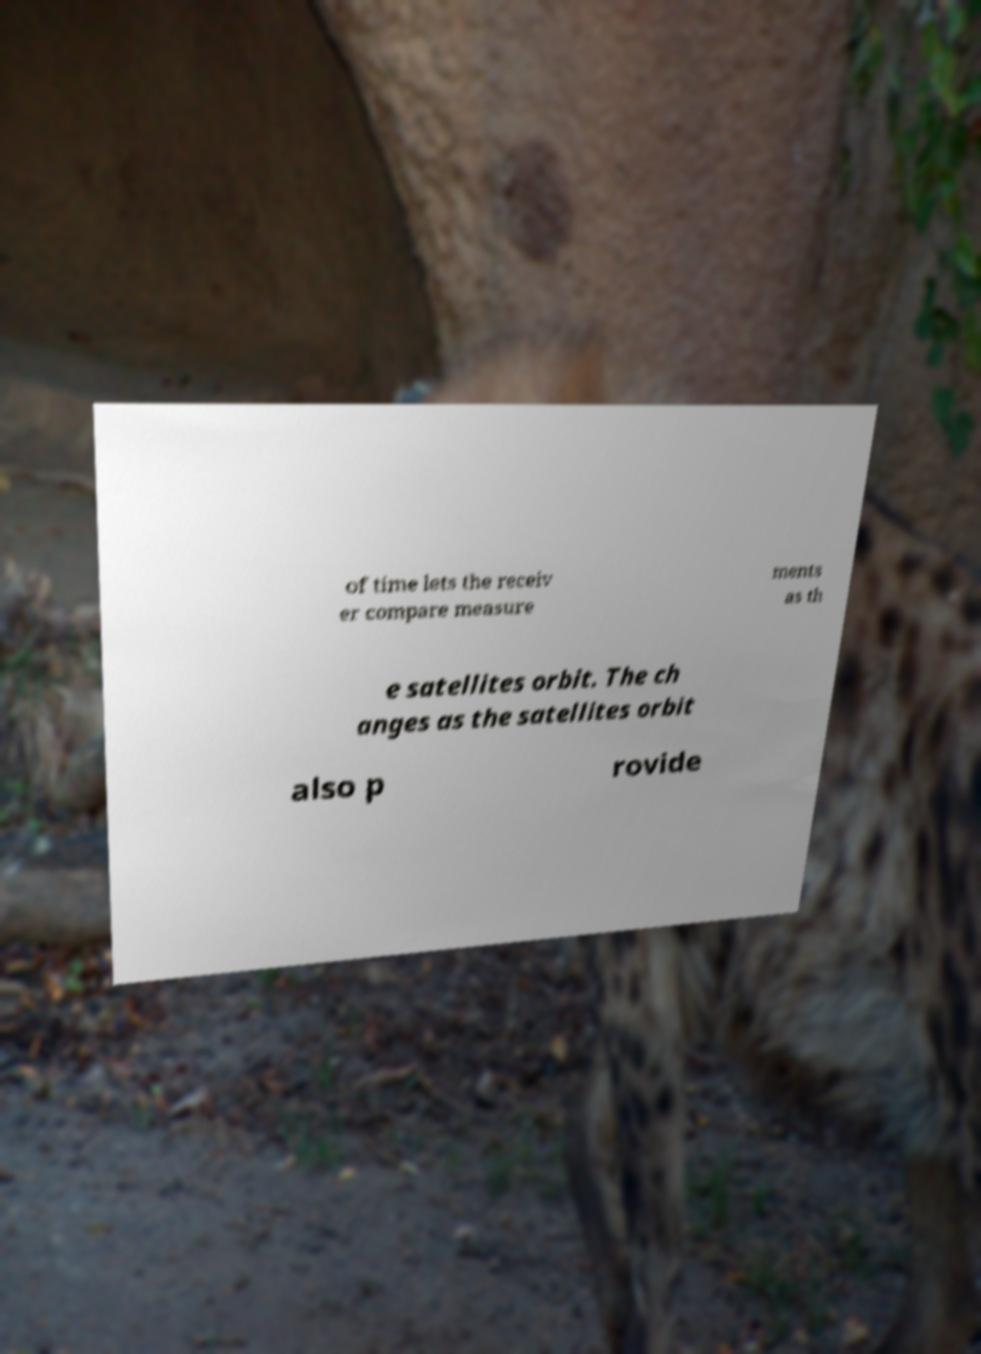Can you accurately transcribe the text from the provided image for me? of time lets the receiv er compare measure ments as th e satellites orbit. The ch anges as the satellites orbit also p rovide 